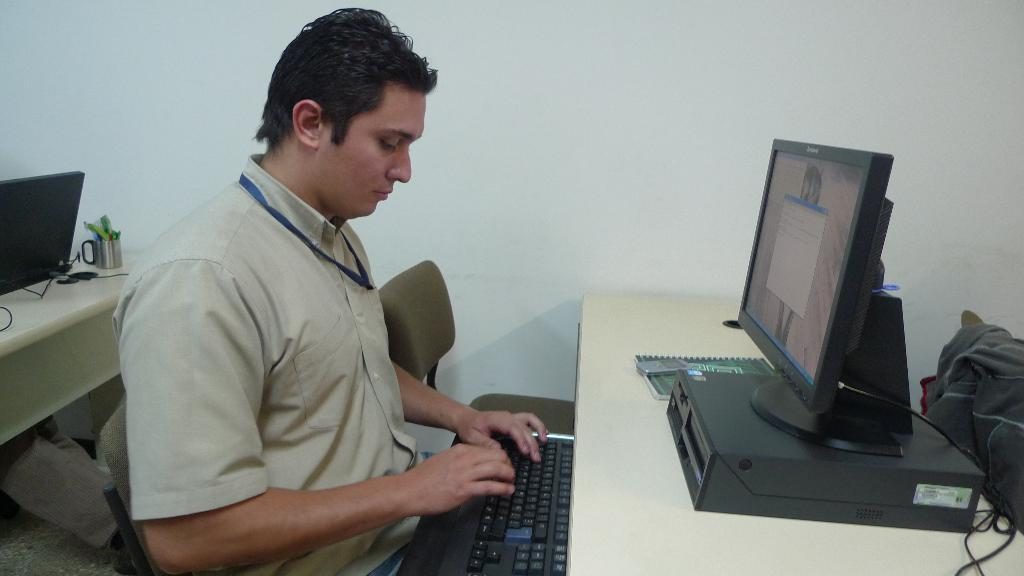What is the main subject of the image? The main subject of the image is a man. What is the man doing in the image? The man is working with a desktop. What type of shock can be seen affecting the man in the image? There is no shock present in the image; the man is simply working with a desktop. What type of fork is visible in the man's hand in the image? There is no fork present in the image; the man is working with a desktop. 